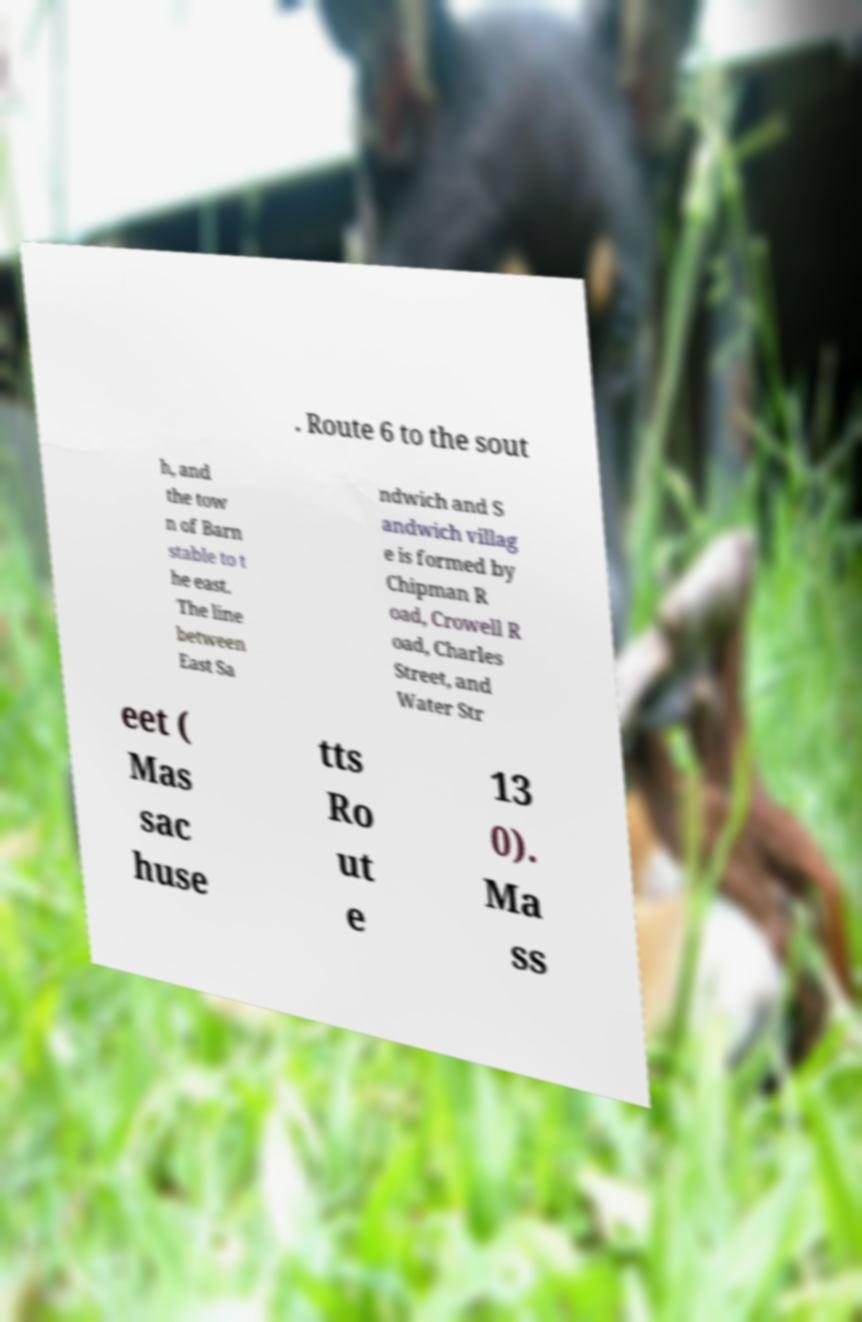Please identify and transcribe the text found in this image. . Route 6 to the sout h, and the tow n of Barn stable to t he east. The line between East Sa ndwich and S andwich villag e is formed by Chipman R oad, Crowell R oad, Charles Street, and Water Str eet ( Mas sac huse tts Ro ut e 13 0). Ma ss 